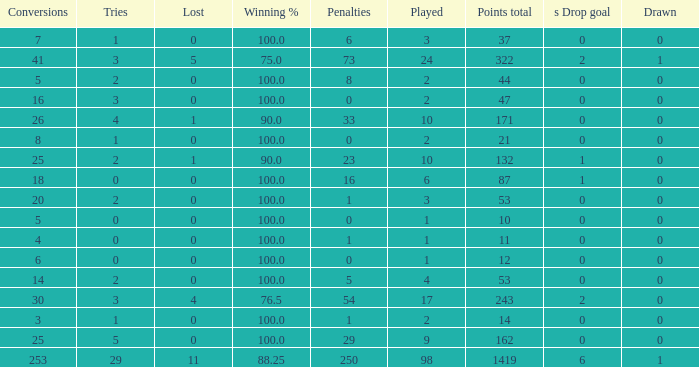How many ties did he have when he had 1 penalties and more than 20 conversions? None. 